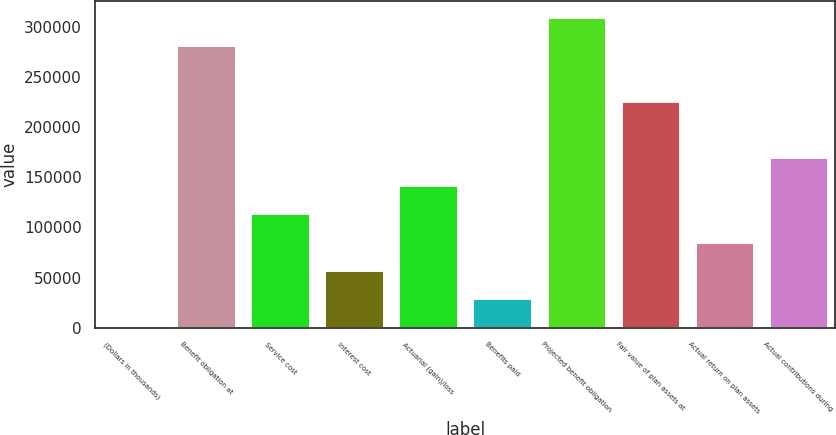<chart> <loc_0><loc_0><loc_500><loc_500><bar_chart><fcel>(Dollars in thousands)<fcel>Benefit obligation at<fcel>Service cost<fcel>Interest cost<fcel>Actuarial (gain)/loss<fcel>Benefits paid<fcel>Projected benefit obligation<fcel>Fair value of plan assets at<fcel>Actual return on plan assets<fcel>Actual contributions during<nl><fcel>2016<fcel>281853<fcel>113951<fcel>57983.4<fcel>141934<fcel>29999.7<fcel>309837<fcel>225886<fcel>85967.1<fcel>169918<nl></chart> 